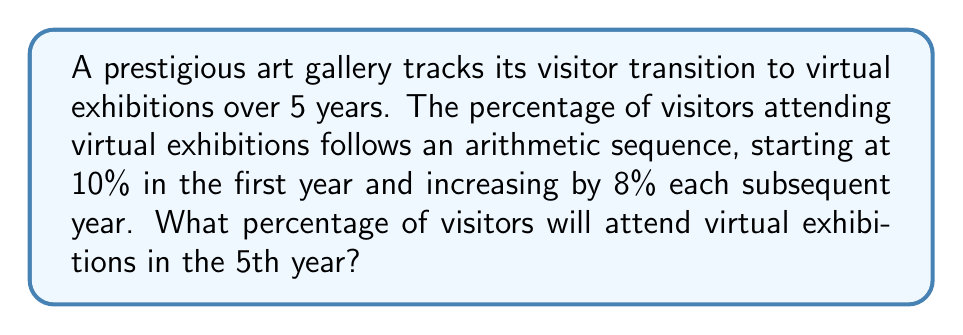What is the answer to this math problem? Let's approach this step-by-step:

1) We're dealing with an arithmetic sequence where:
   - First term (a₁) = 10%
   - Common difference (d) = 8%
   - We need to find the 5th term (a₅)

2) The formula for the nth term of an arithmetic sequence is:
   $a_n = a_1 + (n-1)d$

3) Substituting our values:
   $a_5 = 10 + (5-1)8$

4) Simplify:
   $a_5 = 10 + (4)(8)$
   $a_5 = 10 + 32$
   $a_5 = 42$

5) Therefore, in the 5th year, 42% of visitors will attend virtual exhibitions.
Answer: 42% 